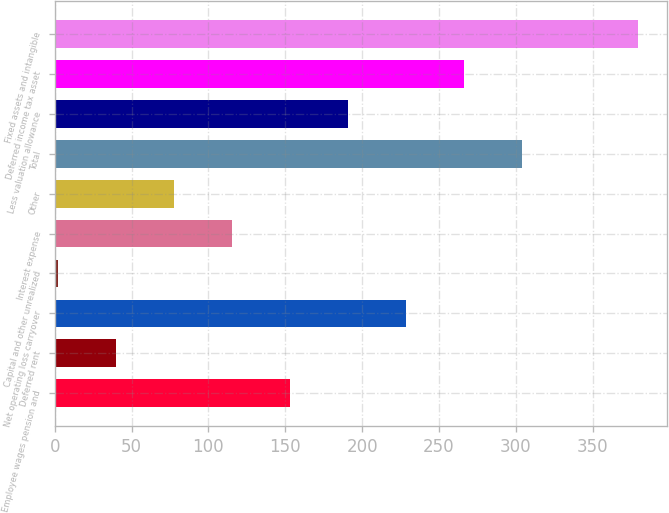Convert chart. <chart><loc_0><loc_0><loc_500><loc_500><bar_chart><fcel>Employee wages pension and<fcel>Deferred rent<fcel>Net operating loss carryover<fcel>Capital and other unrealized<fcel>Interest expense<fcel>Other<fcel>Total<fcel>Less valuation allowance<fcel>Deferred income tax asset<fcel>Fixed assets and intangible<nl><fcel>153.02<fcel>39.83<fcel>228.48<fcel>2.1<fcel>115.29<fcel>77.56<fcel>303.94<fcel>190.75<fcel>266.21<fcel>379.4<nl></chart> 